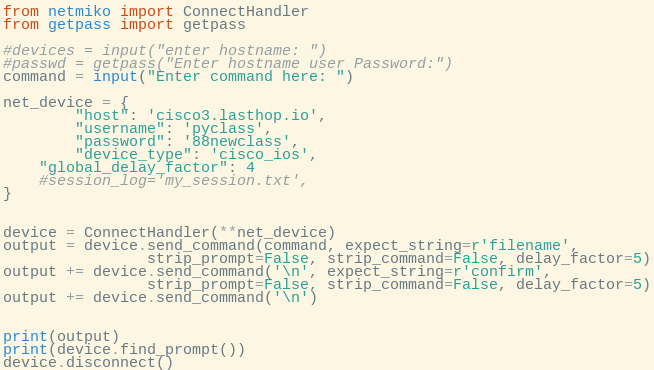<code> <loc_0><loc_0><loc_500><loc_500><_Python_>from netmiko import ConnectHandler
from getpass import getpass

#devices = input("enter hostname: ")
#passwd = getpass("Enter hostname user Password:")
command = input("Enter command here: ")

net_device = {
        "host": 'cisco3.lasthop.io',
        "username": 'pyclass',
        "password": '88newclass',
        "device_type": 'cisco_ios',
	"global_delay_factor": 4
	#session_log='my_session.txt',
}


device = ConnectHandler(**net_device)
output = device.send_command(command, expect_string=r'filename', 
			    strip_prompt=False, strip_command=False, delay_factor=5)
output += device.send_command('\n', expect_string=r'confirm', 
			    strip_prompt=False, strip_command=False, delay_factor=5)
output += device.send_command('\n')


print(output)
print(device.find_prompt())
device.disconnect()




</code> 